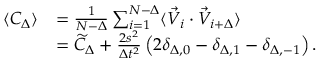Convert formula to latex. <formula><loc_0><loc_0><loc_500><loc_500>\begin{array} { r l } { \langle C _ { \Delta } \rangle } & { = \frac { 1 } { N - \Delta } \sum _ { i = 1 } ^ { N - \Delta } \langle \vec { V } _ { i } \cdot \vec { V } _ { i + \Delta } \rangle } \\ & { = \widetilde { C } _ { \Delta } + \frac { 2 s ^ { 2 } } { \Delta t ^ { 2 } } \left ( 2 \delta _ { \Delta , 0 } - \delta _ { \Delta , 1 } - \delta _ { \Delta , - 1 } \right ) . } \end{array}</formula> 